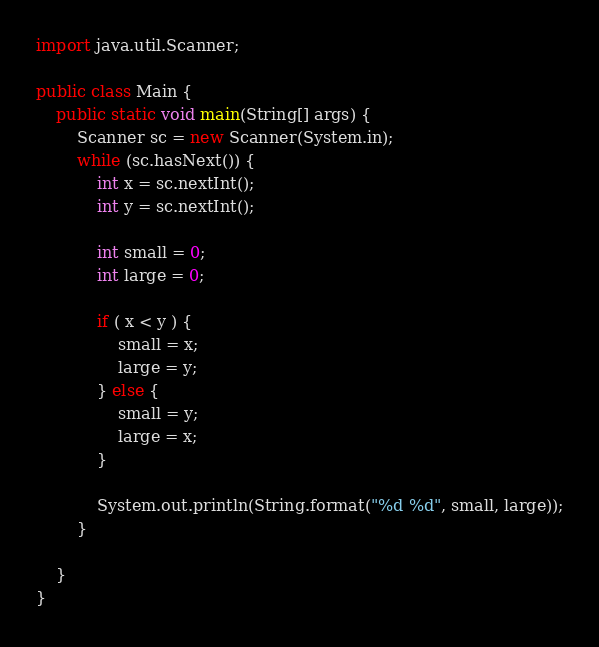Convert code to text. <code><loc_0><loc_0><loc_500><loc_500><_Java_>import java.util.Scanner;

public class Main {
	public static void main(String[] args) {
		Scanner sc = new Scanner(System.in);
        while (sc.hasNext()) {
            int x = sc.nextInt();
            int y = sc.nextInt();
			
			int small = 0;
			int large = 0;
			
			if ( x < y ) {
				small = x;
				large = y;
			} else {
				small = y;
				large = x;
			}
			
            System.out.println(String.format("%d %d", small, large));
        }

	}
}</code> 